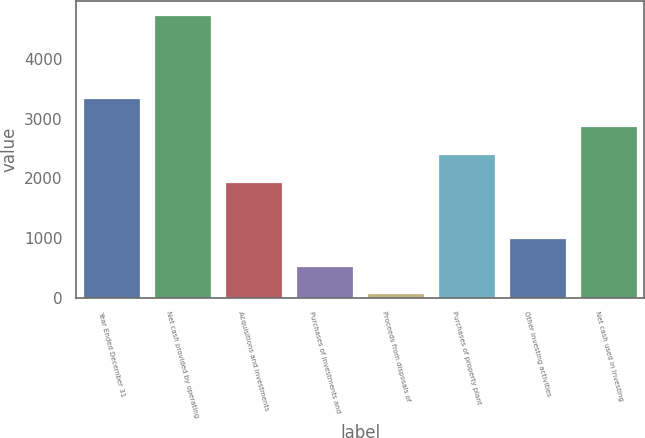<chart> <loc_0><loc_0><loc_500><loc_500><bar_chart><fcel>Year Ended December 31<fcel>Net cash provided by operating<fcel>Acquisitions and investments<fcel>Purchases of investments and<fcel>Proceeds from disposals of<fcel>Purchases of property plant<fcel>Other investing activities<fcel>Net cash used in investing<nl><fcel>3340.1<fcel>4742<fcel>1938.2<fcel>536.3<fcel>69<fcel>2405.5<fcel>1003.6<fcel>2872.8<nl></chart> 